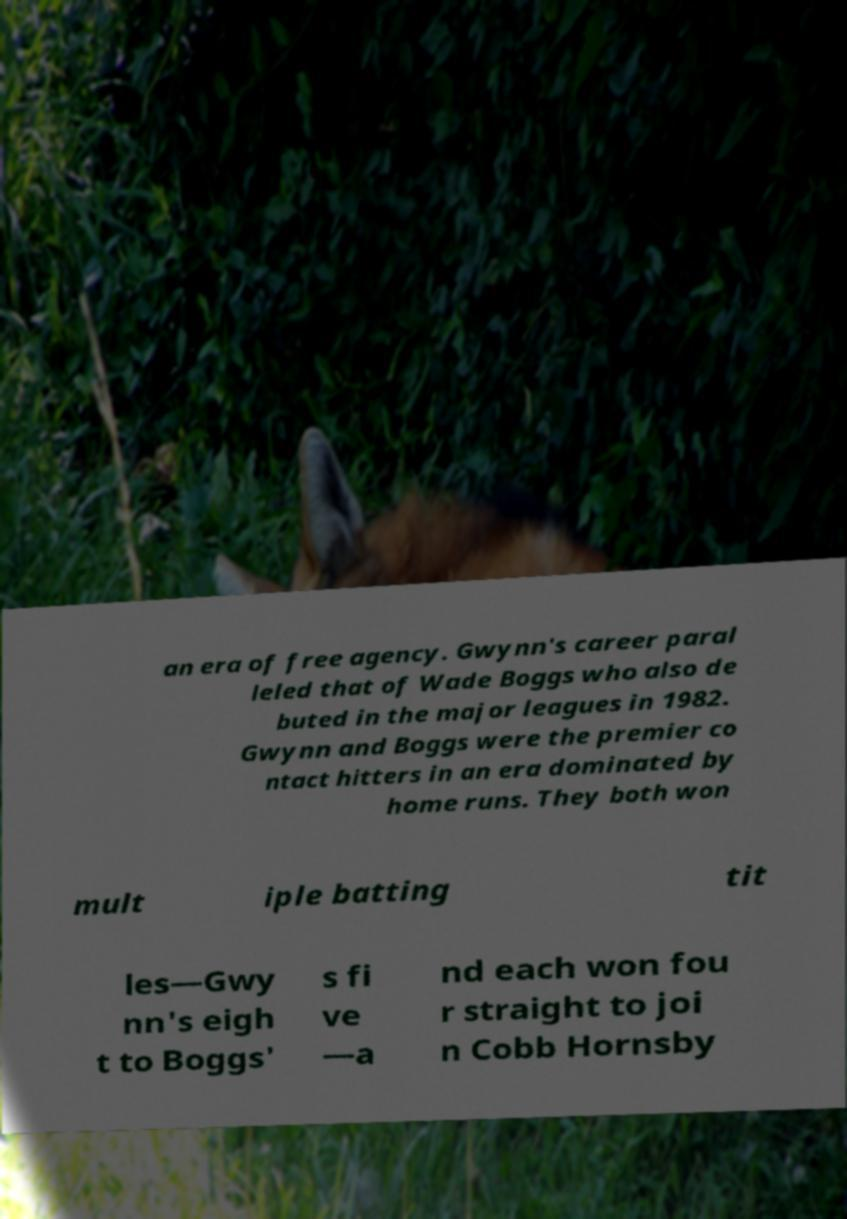I need the written content from this picture converted into text. Can you do that? an era of free agency. Gwynn's career paral leled that of Wade Boggs who also de buted in the major leagues in 1982. Gwynn and Boggs were the premier co ntact hitters in an era dominated by home runs. They both won mult iple batting tit les—Gwy nn's eigh t to Boggs' s fi ve —a nd each won fou r straight to joi n Cobb Hornsby 